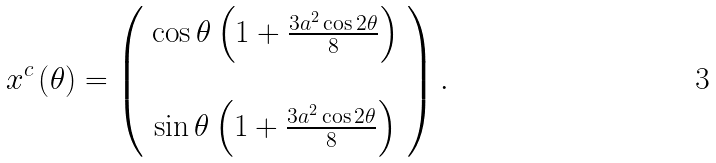Convert formula to latex. <formula><loc_0><loc_0><loc_500><loc_500>x ^ { c } \left ( \theta \right ) = \left ( \begin{array} { c } \cos \theta \left ( 1 + \frac { 3 a ^ { 2 } \cos 2 \theta } { 8 } \right ) \\ \\ \sin \theta \left ( 1 + \frac { 3 a ^ { 2 } \cos 2 \theta } { 8 } \right ) \end{array} \right ) .</formula> 